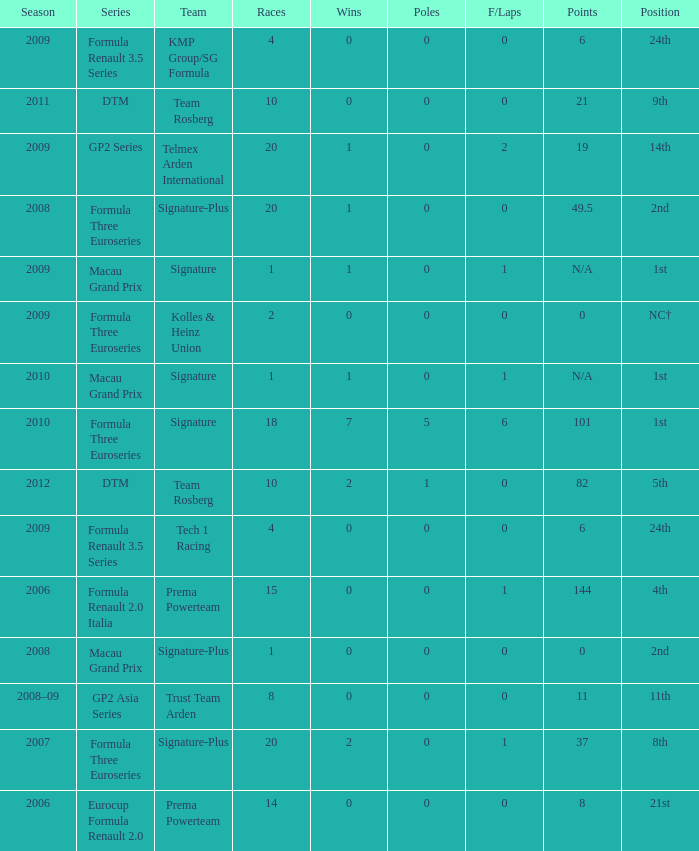How many poles are there in the Formula Three Euroseries in the 2008 season with more than 0 F/Laps? None. 